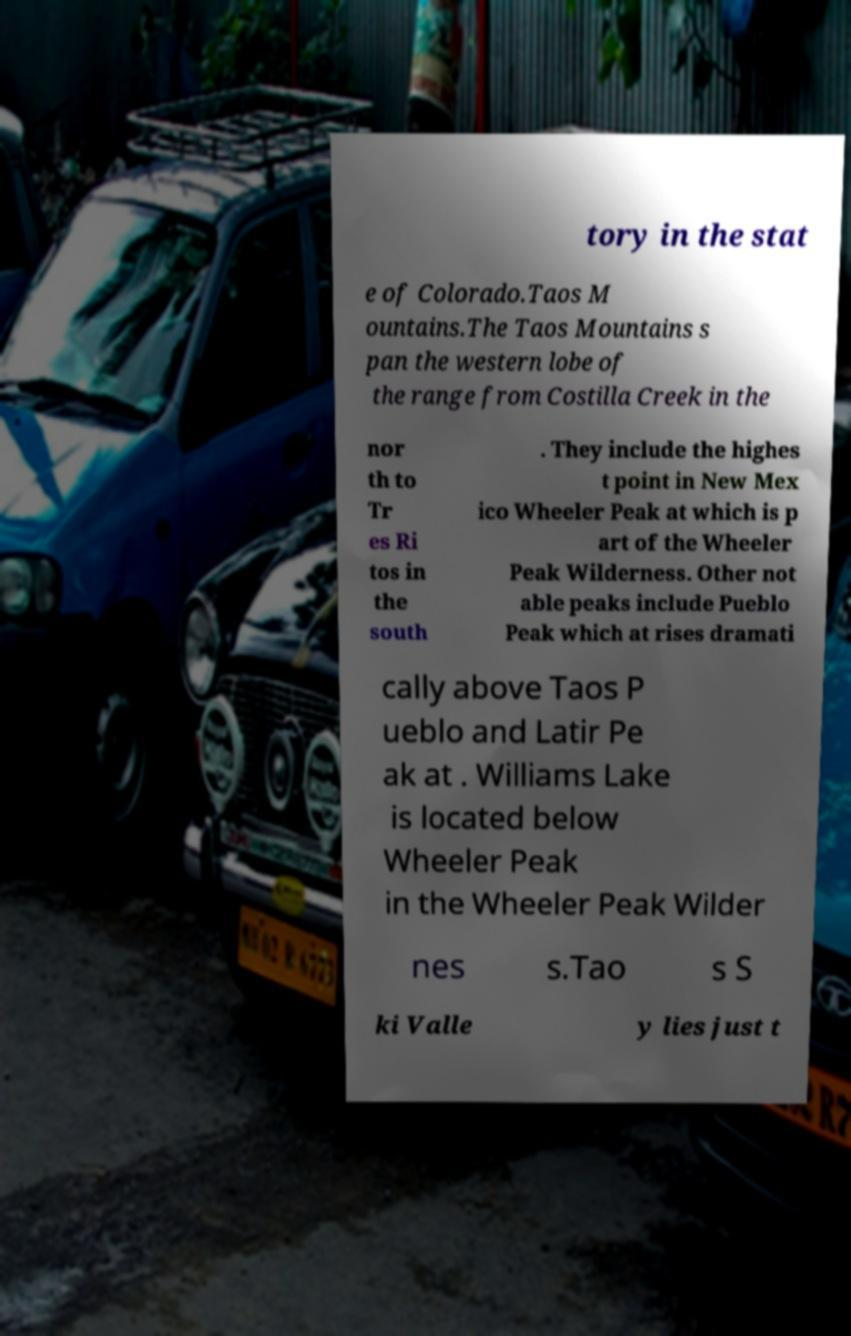Could you extract and type out the text from this image? tory in the stat e of Colorado.Taos M ountains.The Taos Mountains s pan the western lobe of the range from Costilla Creek in the nor th to Tr es Ri tos in the south . They include the highes t point in New Mex ico Wheeler Peak at which is p art of the Wheeler Peak Wilderness. Other not able peaks include Pueblo Peak which at rises dramati cally above Taos P ueblo and Latir Pe ak at . Williams Lake is located below Wheeler Peak in the Wheeler Peak Wilder nes s.Tao s S ki Valle y lies just t 